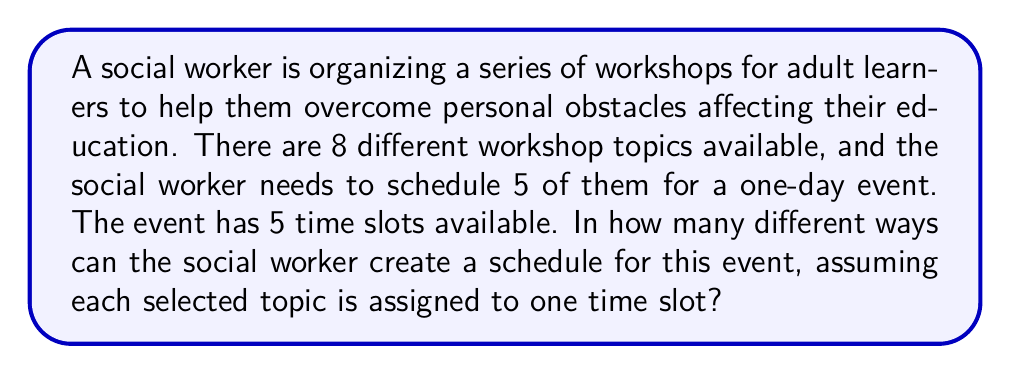Provide a solution to this math problem. Let's approach this problem step-by-step:

1) First, we need to choose 5 topics out of the 8 available. This is a combination problem, as the order of selection doesn't matter. We can represent this as $C(8,5)$ or $\binom{8}{5}$.

2) The number of combinations is calculated using the formula:

   $$\binom{8}{5} = \frac{8!}{5!(8-5)!} = \frac{8!}{5!3!}$$

3) Next, we need to arrange these 5 chosen topics into the 5 time slots. This is a permutation, as the order matters. We can represent this as $P(5,5)$ or simply $5!$.

4) According to the multiplication principle, the total number of possible schedules is the product of the number of ways to choose the topics and the number of ways to arrange them.

5) Therefore, the total number of possible schedules is:

   $$\binom{8}{5} \times 5!$$

6) Let's calculate:
   $$\binom{8}{5} = \frac{8!}{5!3!} = \frac{8 \times 7 \times 6}{3 \times 2 \times 1} = 56$$

7) And $5! = 5 \times 4 \times 3 \times 2 \times 1 = 120$

8) So, the final result is:
   $$56 \times 120 = 6,720$$
Answer: 6,720 